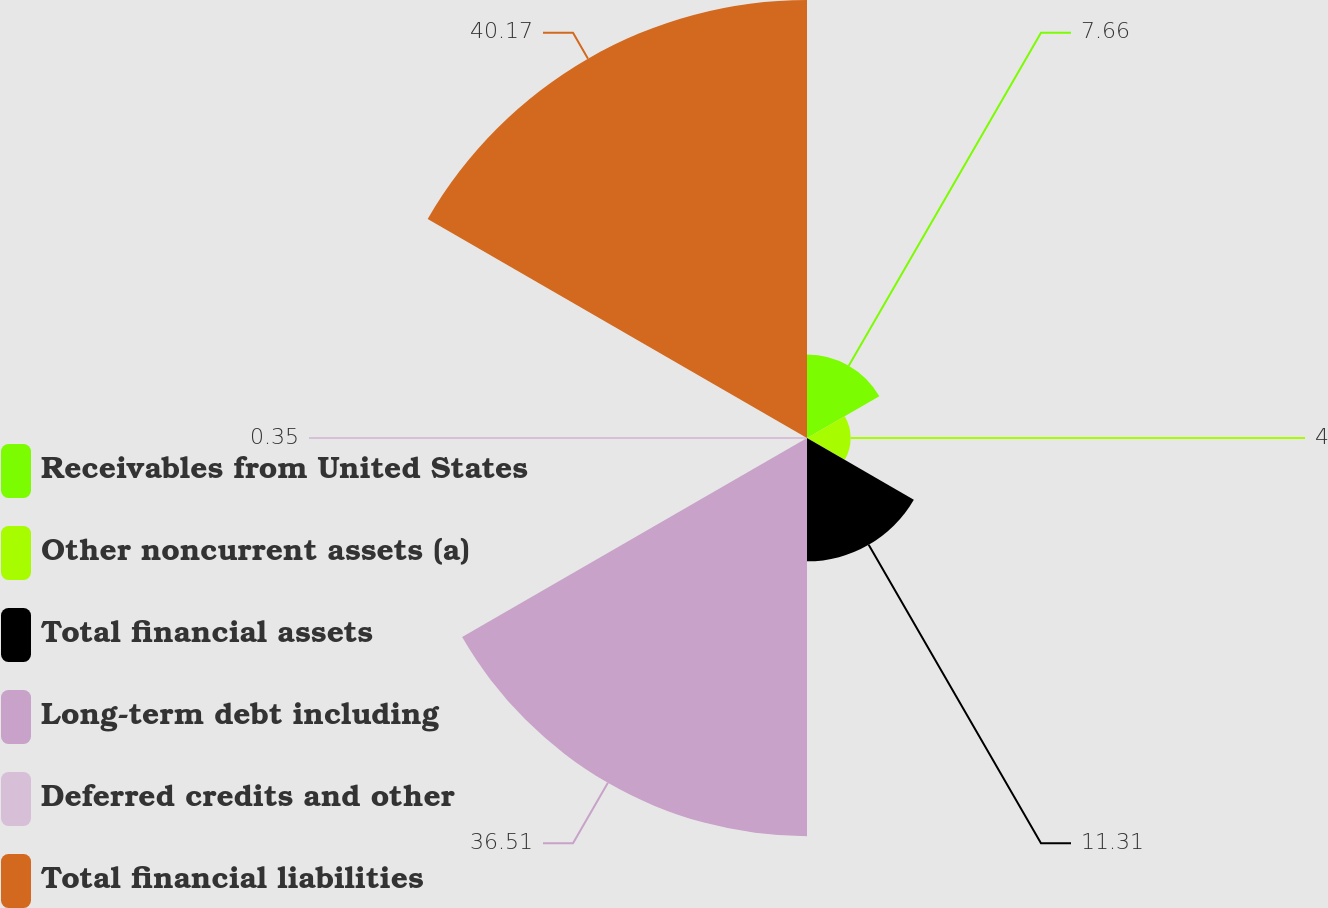Convert chart. <chart><loc_0><loc_0><loc_500><loc_500><pie_chart><fcel>Receivables from United States<fcel>Other noncurrent assets (a)<fcel>Total financial assets<fcel>Long-term debt including<fcel>Deferred credits and other<fcel>Total financial liabilities<nl><fcel>7.66%<fcel>4.0%<fcel>11.31%<fcel>36.51%<fcel>0.35%<fcel>40.16%<nl></chart> 